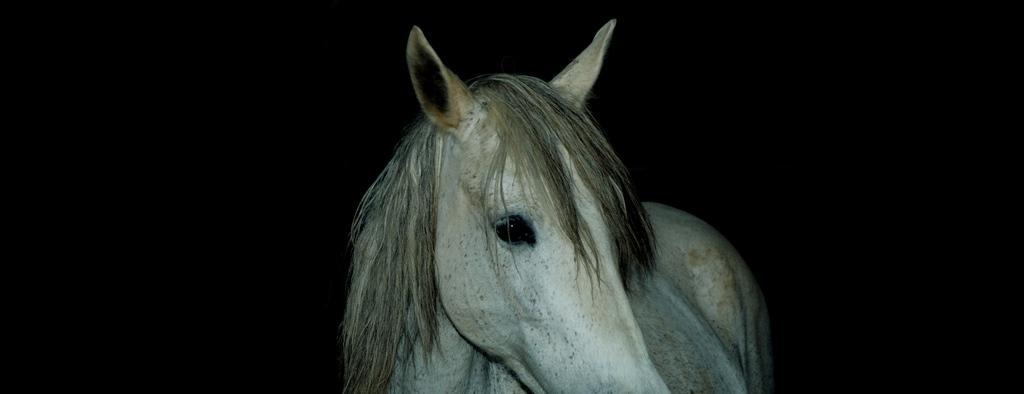What type of animal is in the image? There is a white color horse in the image. What can be observed about the background of the image? The background of the image is dark. How many lizards can be seen crawling on the horse in the image? There are no lizards present in the image; it features a white color horse with a dark background. What type of military vehicle is visible in the image? There is no military vehicle, such as a tank, present in the image. 